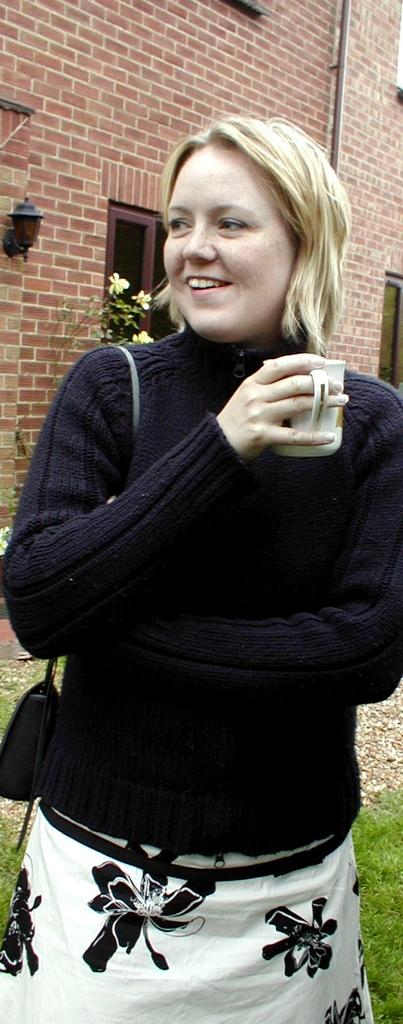Who is present in the image? There is a lady in the image. What is the lady holding in her hands? The lady is holding a bag and a cup. Where is the lady standing? The lady is standing in the grass. What structures can be seen in the image? There is a building and windows in the image. What other objects are present in the image? There is a plant, a light, and a pipe attached to the wall in the image. How many mice are sitting on the throne in the image? There is no throne present in the image, and therefore no mice can be found sitting on it. Are there any chickens visible in the image? There are no chickens present in the image. 